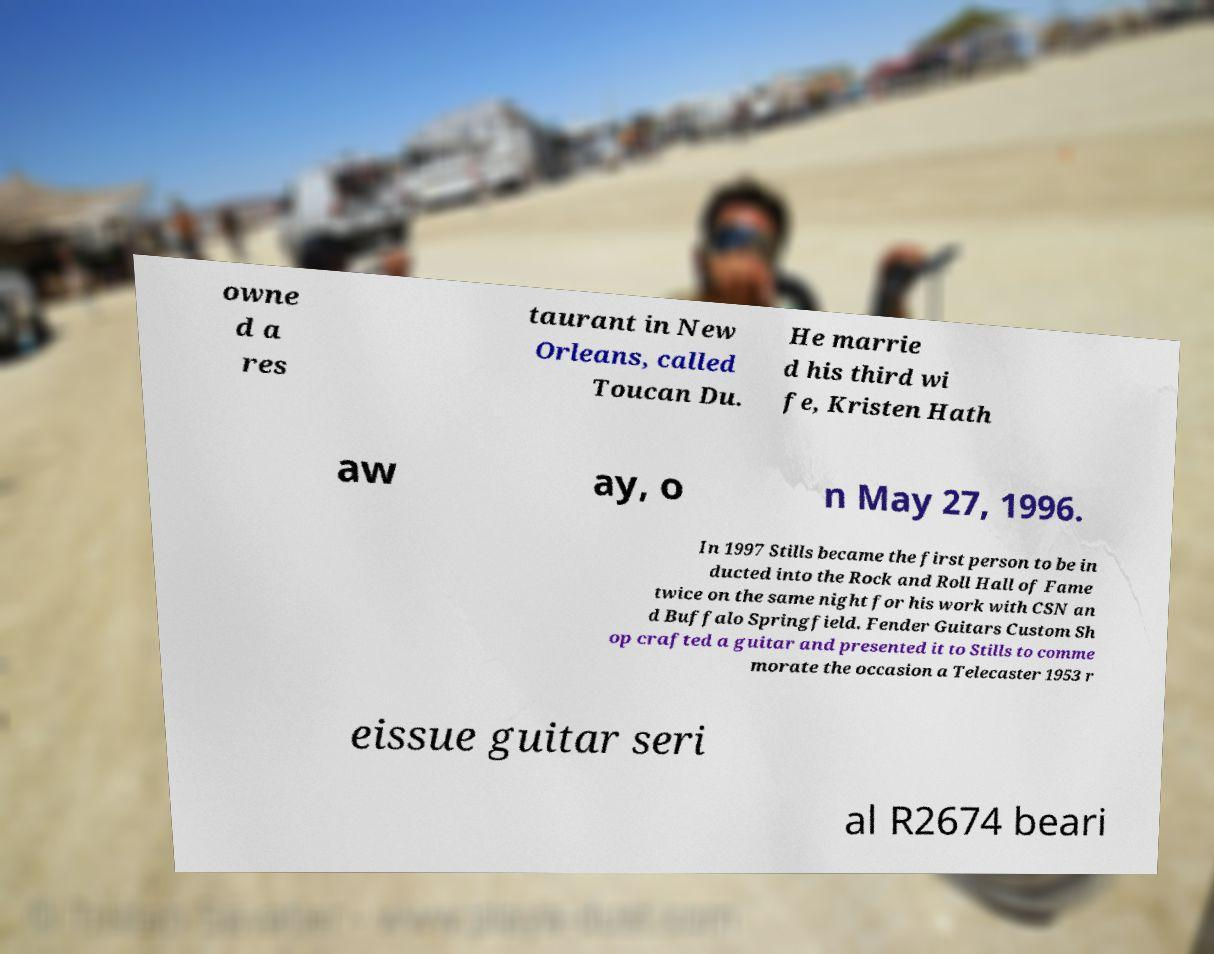Please identify and transcribe the text found in this image. owne d a res taurant in New Orleans, called Toucan Du. He marrie d his third wi fe, Kristen Hath aw ay, o n May 27, 1996. In 1997 Stills became the first person to be in ducted into the Rock and Roll Hall of Fame twice on the same night for his work with CSN an d Buffalo Springfield. Fender Guitars Custom Sh op crafted a guitar and presented it to Stills to comme morate the occasion a Telecaster 1953 r eissue guitar seri al R2674 beari 